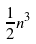<formula> <loc_0><loc_0><loc_500><loc_500>\frac { 1 } { 2 } n ^ { 3 }</formula> 